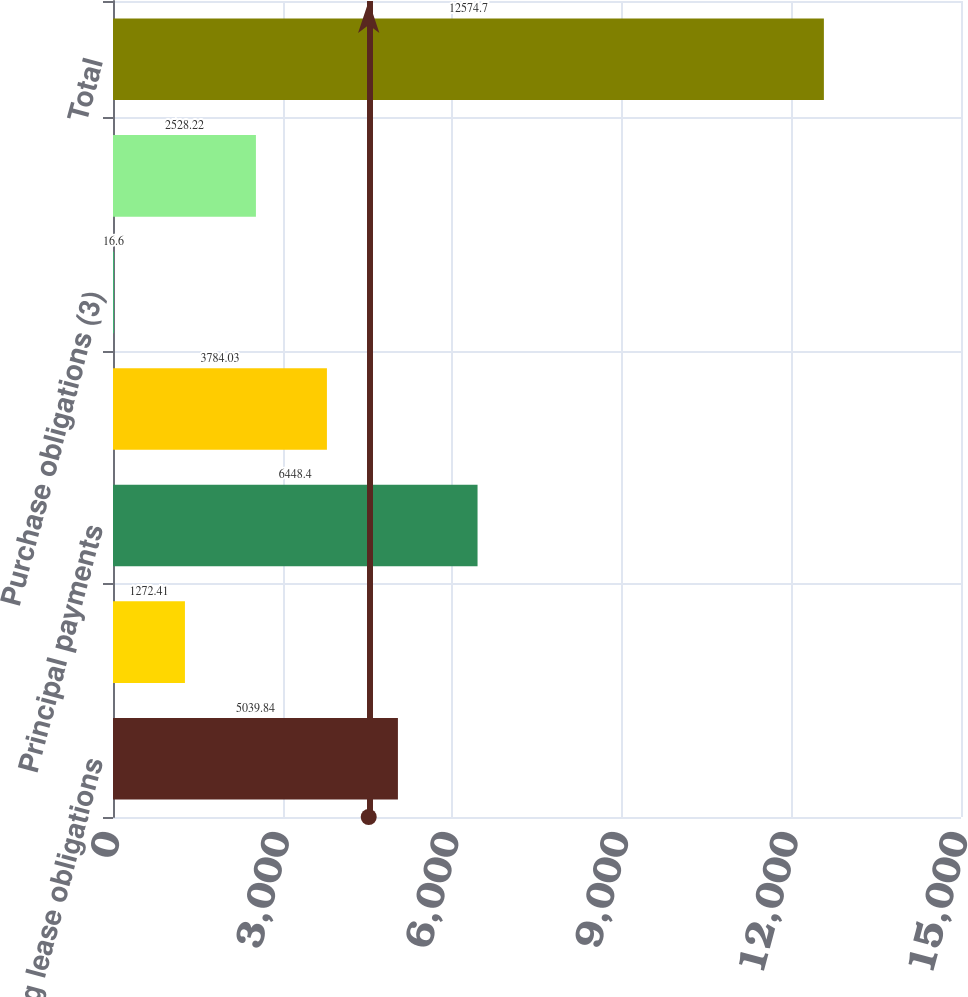Convert chart. <chart><loc_0><loc_0><loc_500><loc_500><bar_chart><fcel>Operating lease obligations<fcel>Financing lease obligations<fcel>Principal payments<fcel>Interest payments<fcel>Purchase obligations (3)<fcel>Other obligations (4)<fcel>Total<nl><fcel>5039.84<fcel>1272.41<fcel>6448.4<fcel>3784.03<fcel>16.6<fcel>2528.22<fcel>12574.7<nl></chart> 